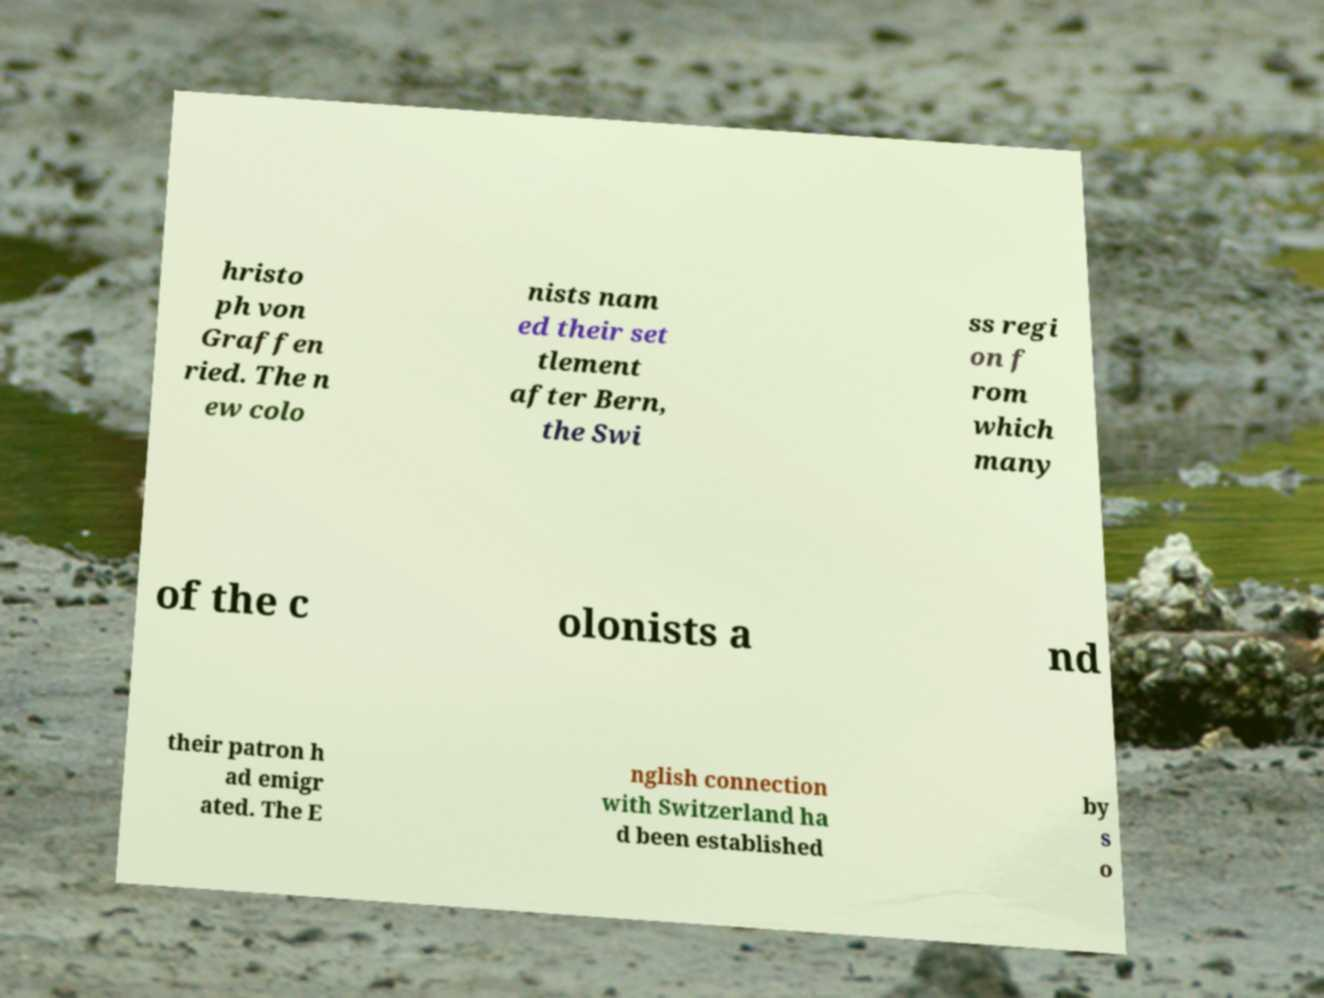Could you assist in decoding the text presented in this image and type it out clearly? hristo ph von Graffen ried. The n ew colo nists nam ed their set tlement after Bern, the Swi ss regi on f rom which many of the c olonists a nd their patron h ad emigr ated. The E nglish connection with Switzerland ha d been established by s o 